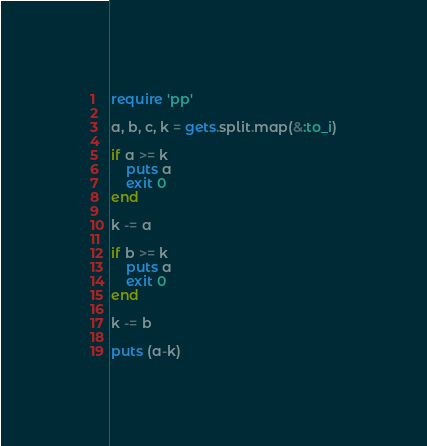<code> <loc_0><loc_0><loc_500><loc_500><_Ruby_>require 'pp'

a, b, c, k = gets.split.map(&:to_i)

if a >= k
    puts a
    exit 0
end

k -= a

if b >= k
    puts a
    exit 0
end

k -= b

puts (a-k)
</code> 